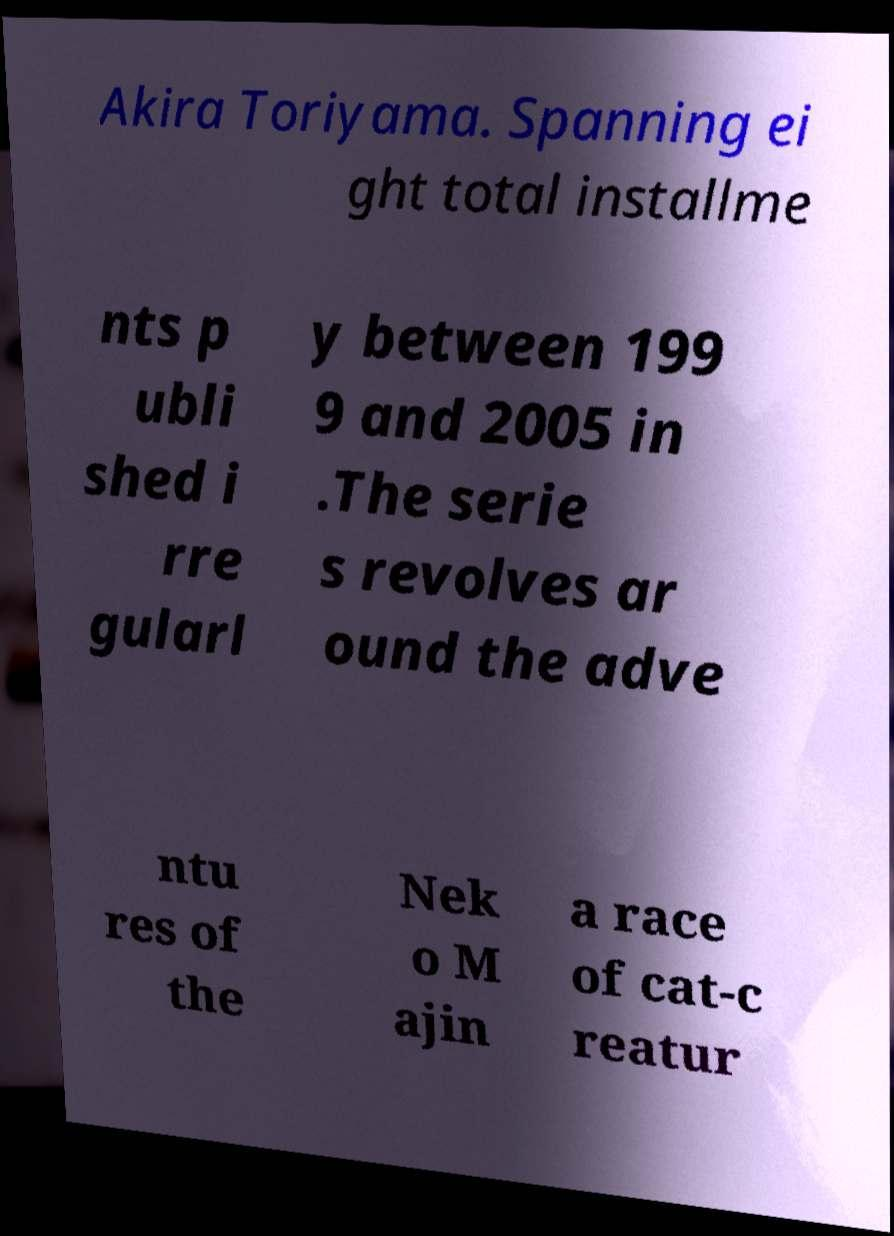What messages or text are displayed in this image? I need them in a readable, typed format. Akira Toriyama. Spanning ei ght total installme nts p ubli shed i rre gularl y between 199 9 and 2005 in .The serie s revolves ar ound the adve ntu res of the Nek o M ajin a race of cat-c reatur 